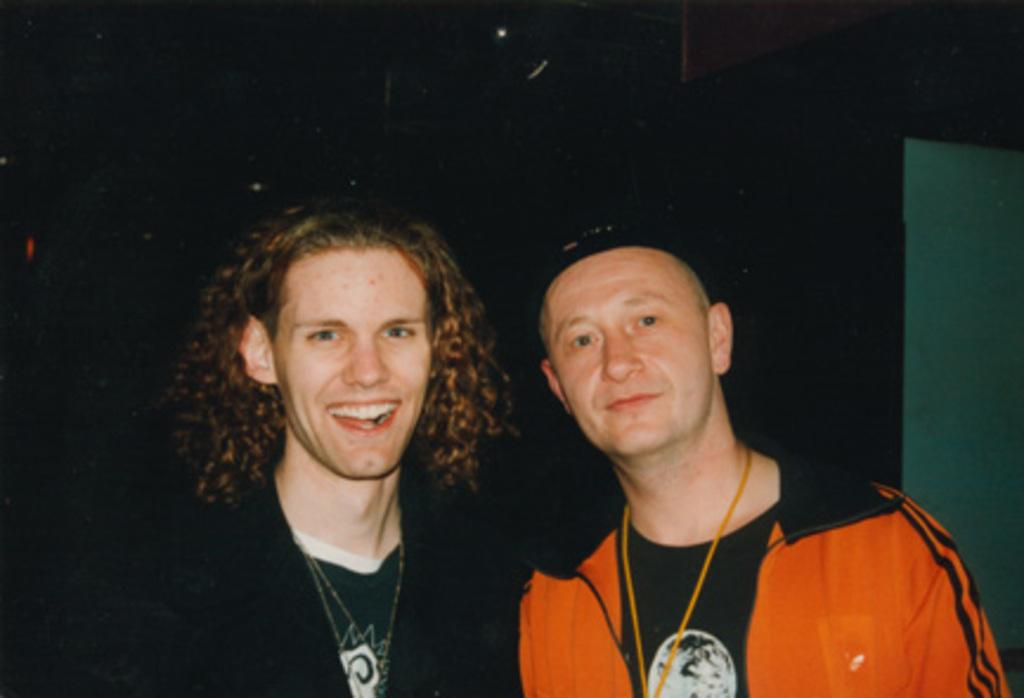How many people are in the image? There are two men in the image. What colors are the jackets of the men in the image? One man is wearing an orange jacket, and the other man is wearing a black jacket. What can be seen in the background of the image? There is a wall in the background of the image. What type of stick is the girl holding in the image? There is no girl or stick present in the image; it features two men wearing jackets. 